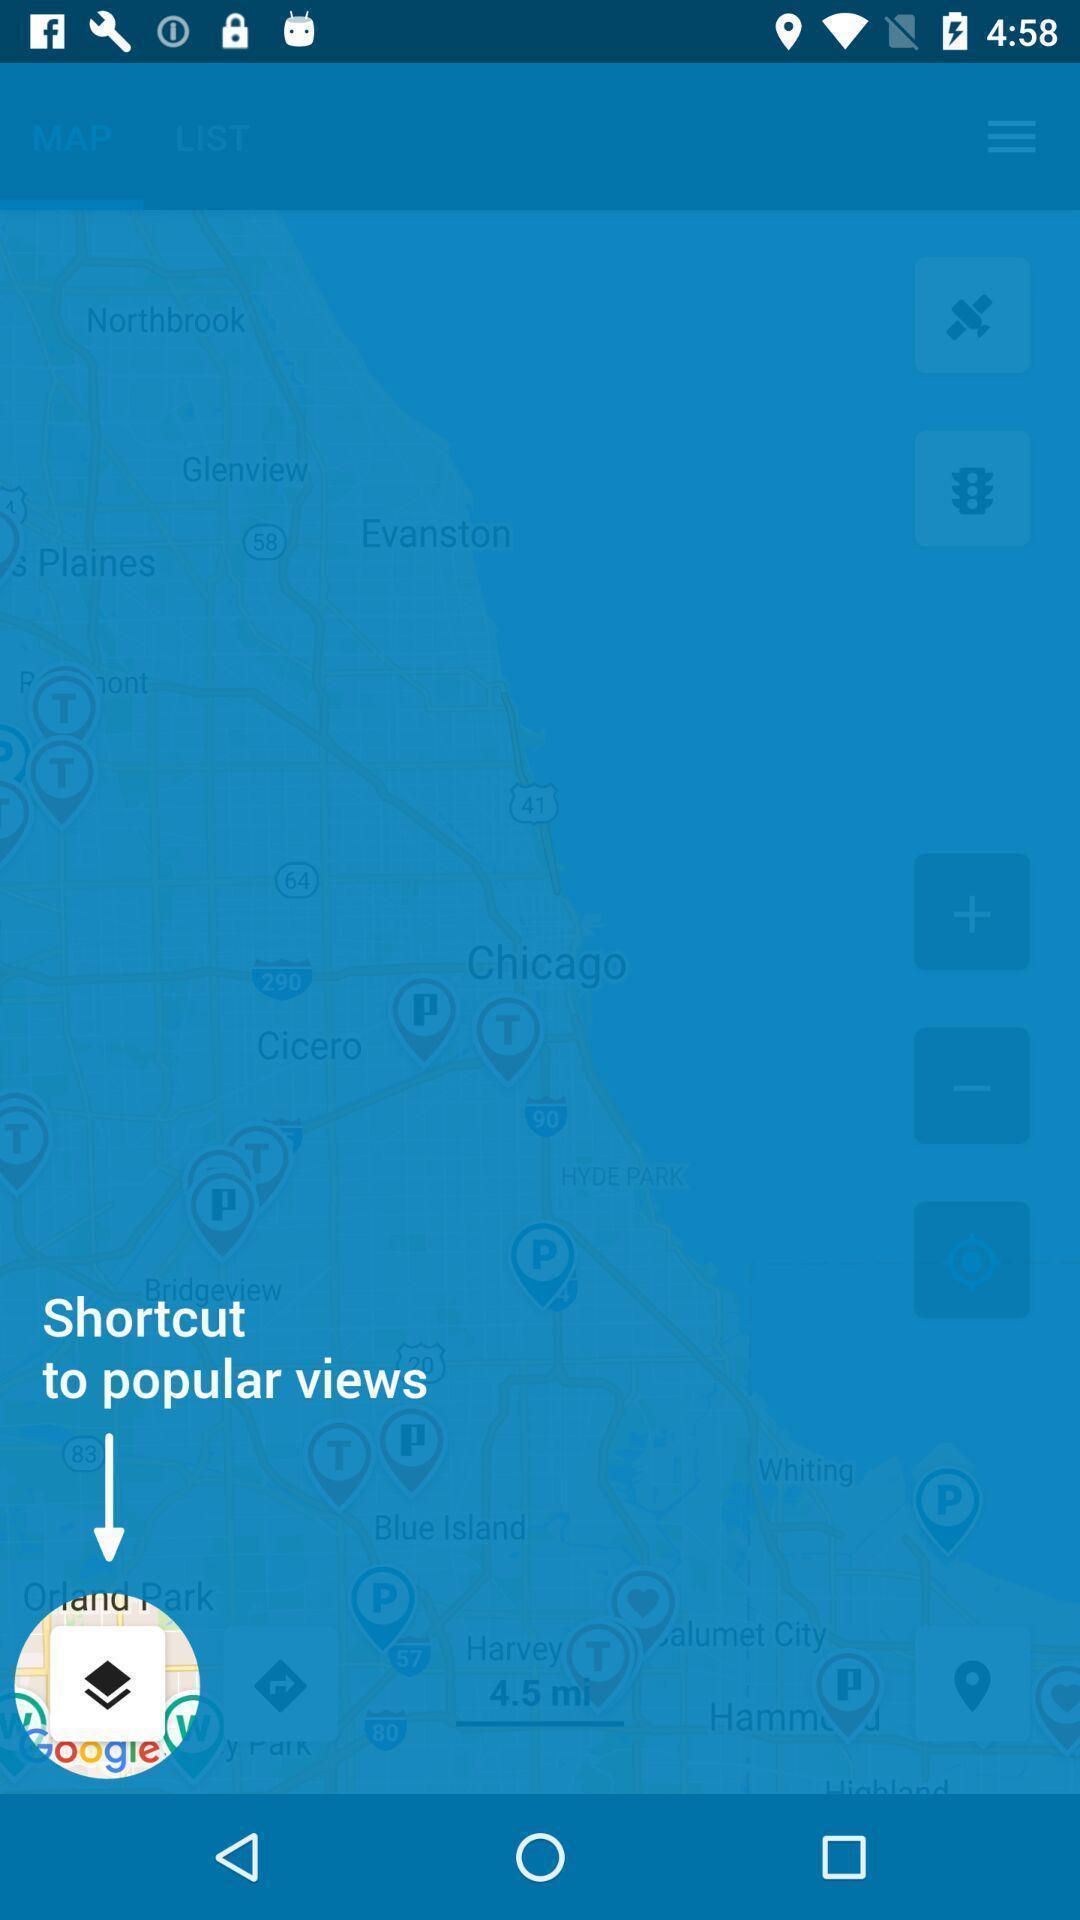Describe this image in words. Page with showing icon in a navigation app. 